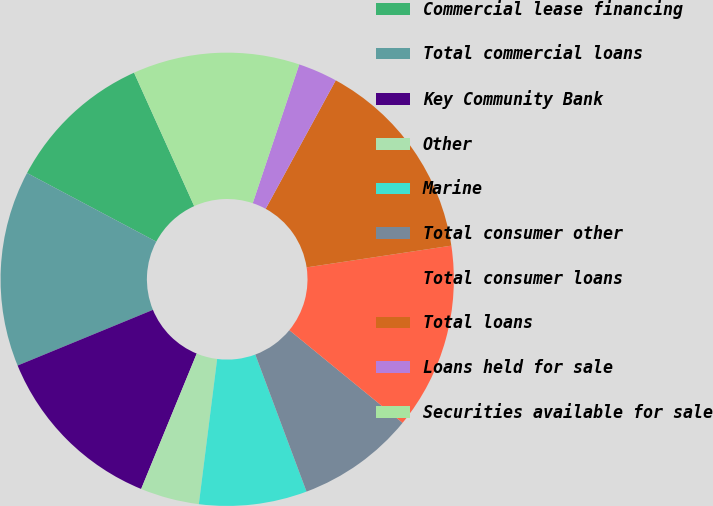Convert chart. <chart><loc_0><loc_0><loc_500><loc_500><pie_chart><fcel>Commercial lease financing<fcel>Total commercial loans<fcel>Key Community Bank<fcel>Other<fcel>Marine<fcel>Total consumer other<fcel>Total consumer loans<fcel>Total loans<fcel>Loans held for sale<fcel>Securities available for sale<nl><fcel>10.49%<fcel>13.98%<fcel>12.59%<fcel>4.2%<fcel>7.69%<fcel>8.39%<fcel>13.29%<fcel>14.68%<fcel>2.8%<fcel>11.89%<nl></chart> 